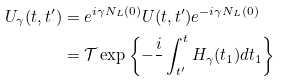Convert formula to latex. <formula><loc_0><loc_0><loc_500><loc_500>U _ { \gamma } ( t , t ^ { \prime } ) & = e ^ { i \gamma N _ { L } ( 0 ) } U ( t , t ^ { \prime } ) e ^ { - i \gamma N _ { L } ( 0 ) } \\ & = \mathcal { T } \exp \left \{ - \frac { i } { } \int _ { t ^ { \prime } } ^ { t } H _ { \gamma } ( t _ { 1 } ) d t _ { 1 } \right \}</formula> 